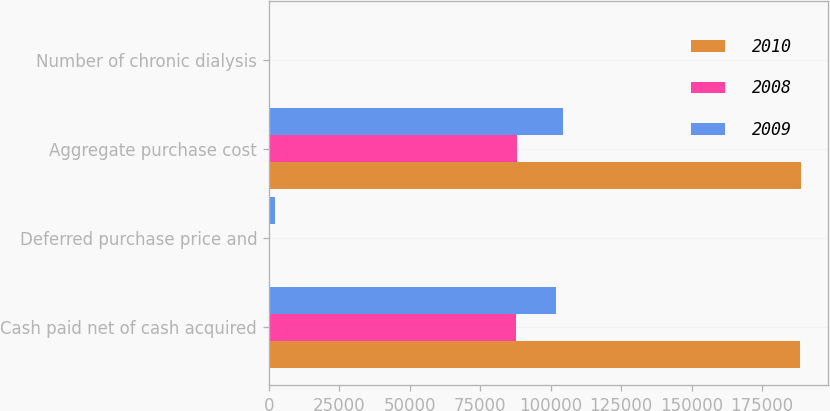Convert chart. <chart><loc_0><loc_0><loc_500><loc_500><stacked_bar_chart><ecel><fcel>Cash paid net of cash acquired<fcel>Deferred purchase price and<fcel>Aggregate purchase cost<fcel>Number of chronic dialysis<nl><fcel>2010<fcel>188502<fcel>449<fcel>188951<fcel>41<nl><fcel>2008<fcel>87617<fcel>338<fcel>87955<fcel>19<nl><fcel>2009<fcel>101959<fcel>2286<fcel>104245<fcel>20<nl></chart> 